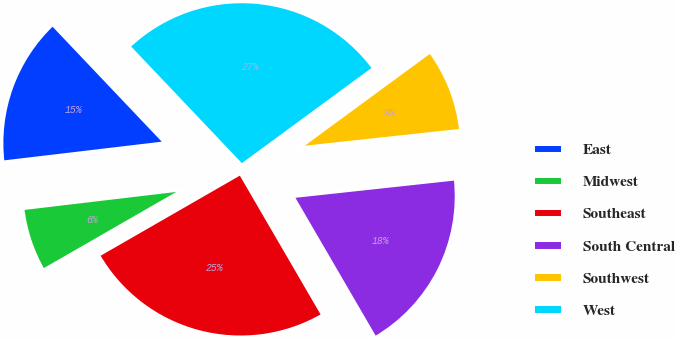Convert chart to OTSL. <chart><loc_0><loc_0><loc_500><loc_500><pie_chart><fcel>East<fcel>Midwest<fcel>Southeast<fcel>South Central<fcel>Southwest<fcel>West<nl><fcel>14.79%<fcel>6.43%<fcel>25.08%<fcel>18.33%<fcel>8.36%<fcel>27.01%<nl></chart> 